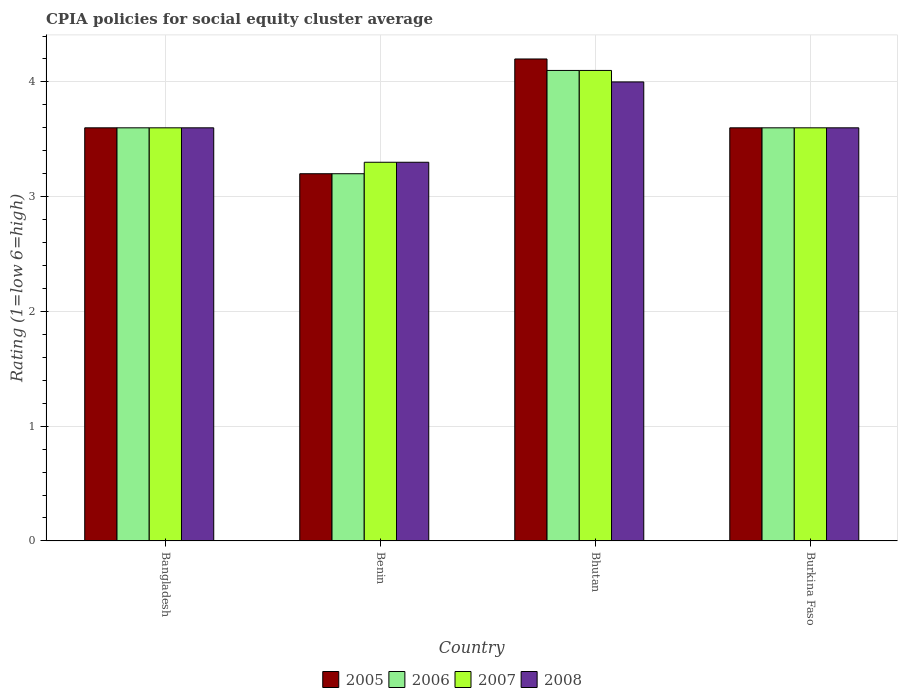How many groups of bars are there?
Provide a succinct answer. 4. How many bars are there on the 1st tick from the left?
Offer a terse response. 4. What is the label of the 2nd group of bars from the left?
Provide a succinct answer. Benin. Across all countries, what is the maximum CPIA rating in 2007?
Your answer should be very brief. 4.1. In which country was the CPIA rating in 2006 maximum?
Provide a succinct answer. Bhutan. In which country was the CPIA rating in 2007 minimum?
Provide a short and direct response. Benin. What is the total CPIA rating in 2008 in the graph?
Provide a succinct answer. 14.5. What is the difference between the CPIA rating in 2006 in Bangladesh and that in Burkina Faso?
Give a very brief answer. 0. What is the difference between the CPIA rating in 2007 in Benin and the CPIA rating in 2006 in Bangladesh?
Make the answer very short. -0.3. What is the average CPIA rating in 2007 per country?
Provide a short and direct response. 3.65. In how many countries, is the CPIA rating in 2007 greater than 2.2?
Your response must be concise. 4. What is the ratio of the CPIA rating in 2006 in Bangladesh to that in Burkina Faso?
Offer a terse response. 1. Is the CPIA rating in 2007 in Bhutan less than that in Burkina Faso?
Provide a succinct answer. No. Is the difference between the CPIA rating in 2008 in Bhutan and Burkina Faso greater than the difference between the CPIA rating in 2007 in Bhutan and Burkina Faso?
Provide a short and direct response. No. What is the difference between the highest and the second highest CPIA rating in 2007?
Provide a succinct answer. -0.5. Is the sum of the CPIA rating in 2008 in Benin and Burkina Faso greater than the maximum CPIA rating in 2006 across all countries?
Keep it short and to the point. Yes. Is it the case that in every country, the sum of the CPIA rating in 2008 and CPIA rating in 2007 is greater than the sum of CPIA rating in 2006 and CPIA rating in 2005?
Your response must be concise. No. What does the 1st bar from the right in Burkina Faso represents?
Make the answer very short. 2008. Are all the bars in the graph horizontal?
Ensure brevity in your answer.  No. Are the values on the major ticks of Y-axis written in scientific E-notation?
Your answer should be very brief. No. Does the graph contain any zero values?
Give a very brief answer. No. Does the graph contain grids?
Your response must be concise. Yes. How are the legend labels stacked?
Provide a short and direct response. Horizontal. What is the title of the graph?
Make the answer very short. CPIA policies for social equity cluster average. Does "1982" appear as one of the legend labels in the graph?
Your answer should be very brief. No. What is the label or title of the Y-axis?
Ensure brevity in your answer.  Rating (1=low 6=high). What is the Rating (1=low 6=high) of 2008 in Bangladesh?
Your response must be concise. 3.6. What is the Rating (1=low 6=high) of 2005 in Benin?
Ensure brevity in your answer.  3.2. What is the Rating (1=low 6=high) of 2008 in Benin?
Ensure brevity in your answer.  3.3. What is the Rating (1=low 6=high) in 2005 in Bhutan?
Provide a succinct answer. 4.2. What is the Rating (1=low 6=high) in 2008 in Bhutan?
Provide a short and direct response. 4. What is the Rating (1=low 6=high) of 2005 in Burkina Faso?
Provide a succinct answer. 3.6. What is the Rating (1=low 6=high) in 2008 in Burkina Faso?
Offer a terse response. 3.6. Across all countries, what is the maximum Rating (1=low 6=high) in 2005?
Make the answer very short. 4.2. Across all countries, what is the maximum Rating (1=low 6=high) of 2006?
Make the answer very short. 4.1. Across all countries, what is the maximum Rating (1=low 6=high) of 2007?
Offer a terse response. 4.1. Across all countries, what is the maximum Rating (1=low 6=high) in 2008?
Offer a very short reply. 4. Across all countries, what is the minimum Rating (1=low 6=high) of 2007?
Make the answer very short. 3.3. Across all countries, what is the minimum Rating (1=low 6=high) of 2008?
Your answer should be very brief. 3.3. What is the total Rating (1=low 6=high) of 2005 in the graph?
Your response must be concise. 14.6. What is the total Rating (1=low 6=high) in 2006 in the graph?
Your response must be concise. 14.5. What is the total Rating (1=low 6=high) of 2007 in the graph?
Your answer should be very brief. 14.6. What is the difference between the Rating (1=low 6=high) in 2005 in Bangladesh and that in Benin?
Keep it short and to the point. 0.4. What is the difference between the Rating (1=low 6=high) of 2006 in Bangladesh and that in Benin?
Offer a very short reply. 0.4. What is the difference between the Rating (1=low 6=high) of 2007 in Bangladesh and that in Benin?
Ensure brevity in your answer.  0.3. What is the difference between the Rating (1=low 6=high) in 2008 in Bangladesh and that in Benin?
Provide a succinct answer. 0.3. What is the difference between the Rating (1=low 6=high) of 2006 in Bangladesh and that in Bhutan?
Your answer should be very brief. -0.5. What is the difference between the Rating (1=low 6=high) in 2007 in Bangladesh and that in Bhutan?
Your response must be concise. -0.5. What is the difference between the Rating (1=low 6=high) of 2006 in Bangladesh and that in Burkina Faso?
Your answer should be compact. 0. What is the difference between the Rating (1=low 6=high) of 2008 in Bangladesh and that in Burkina Faso?
Give a very brief answer. 0. What is the difference between the Rating (1=low 6=high) of 2006 in Benin and that in Bhutan?
Give a very brief answer. -0.9. What is the difference between the Rating (1=low 6=high) of 2008 in Benin and that in Bhutan?
Provide a succinct answer. -0.7. What is the difference between the Rating (1=low 6=high) in 2005 in Benin and that in Burkina Faso?
Your answer should be very brief. -0.4. What is the difference between the Rating (1=low 6=high) of 2006 in Benin and that in Burkina Faso?
Your answer should be compact. -0.4. What is the difference between the Rating (1=low 6=high) in 2007 in Benin and that in Burkina Faso?
Your answer should be compact. -0.3. What is the difference between the Rating (1=low 6=high) of 2008 in Benin and that in Burkina Faso?
Offer a very short reply. -0.3. What is the difference between the Rating (1=low 6=high) of 2005 in Bangladesh and the Rating (1=low 6=high) of 2007 in Benin?
Your answer should be compact. 0.3. What is the difference between the Rating (1=low 6=high) in 2005 in Bangladesh and the Rating (1=low 6=high) in 2008 in Benin?
Ensure brevity in your answer.  0.3. What is the difference between the Rating (1=low 6=high) of 2006 in Bangladesh and the Rating (1=low 6=high) of 2007 in Benin?
Make the answer very short. 0.3. What is the difference between the Rating (1=low 6=high) in 2007 in Bangladesh and the Rating (1=low 6=high) in 2008 in Benin?
Ensure brevity in your answer.  0.3. What is the difference between the Rating (1=low 6=high) in 2005 in Bangladesh and the Rating (1=low 6=high) in 2007 in Bhutan?
Offer a very short reply. -0.5. What is the difference between the Rating (1=low 6=high) of 2006 in Bangladesh and the Rating (1=low 6=high) of 2008 in Bhutan?
Your answer should be very brief. -0.4. What is the difference between the Rating (1=low 6=high) in 2005 in Bangladesh and the Rating (1=low 6=high) in 2007 in Burkina Faso?
Your response must be concise. 0. What is the difference between the Rating (1=low 6=high) of 2006 in Bangladesh and the Rating (1=low 6=high) of 2007 in Burkina Faso?
Give a very brief answer. 0. What is the difference between the Rating (1=low 6=high) in 2006 in Bangladesh and the Rating (1=low 6=high) in 2008 in Burkina Faso?
Your answer should be compact. 0. What is the difference between the Rating (1=low 6=high) of 2007 in Bangladesh and the Rating (1=low 6=high) of 2008 in Burkina Faso?
Offer a terse response. 0. What is the difference between the Rating (1=low 6=high) of 2005 in Benin and the Rating (1=low 6=high) of 2008 in Bhutan?
Offer a terse response. -0.8. What is the difference between the Rating (1=low 6=high) in 2006 in Benin and the Rating (1=low 6=high) in 2007 in Bhutan?
Provide a short and direct response. -0.9. What is the difference between the Rating (1=low 6=high) in 2005 in Benin and the Rating (1=low 6=high) in 2006 in Burkina Faso?
Offer a terse response. -0.4. What is the difference between the Rating (1=low 6=high) of 2005 in Benin and the Rating (1=low 6=high) of 2007 in Burkina Faso?
Provide a succinct answer. -0.4. What is the difference between the Rating (1=low 6=high) of 2005 in Benin and the Rating (1=low 6=high) of 2008 in Burkina Faso?
Offer a terse response. -0.4. What is the difference between the Rating (1=low 6=high) in 2006 in Benin and the Rating (1=low 6=high) in 2007 in Burkina Faso?
Offer a terse response. -0.4. What is the difference between the Rating (1=low 6=high) of 2006 in Benin and the Rating (1=low 6=high) of 2008 in Burkina Faso?
Give a very brief answer. -0.4. What is the difference between the Rating (1=low 6=high) of 2005 in Bhutan and the Rating (1=low 6=high) of 2006 in Burkina Faso?
Your answer should be very brief. 0.6. What is the difference between the Rating (1=low 6=high) in 2005 in Bhutan and the Rating (1=low 6=high) in 2007 in Burkina Faso?
Your answer should be very brief. 0.6. What is the difference between the Rating (1=low 6=high) of 2005 in Bhutan and the Rating (1=low 6=high) of 2008 in Burkina Faso?
Offer a terse response. 0.6. What is the difference between the Rating (1=low 6=high) in 2006 in Bhutan and the Rating (1=low 6=high) in 2007 in Burkina Faso?
Keep it short and to the point. 0.5. What is the difference between the Rating (1=low 6=high) of 2006 in Bhutan and the Rating (1=low 6=high) of 2008 in Burkina Faso?
Your answer should be compact. 0.5. What is the average Rating (1=low 6=high) in 2005 per country?
Keep it short and to the point. 3.65. What is the average Rating (1=low 6=high) of 2006 per country?
Keep it short and to the point. 3.62. What is the average Rating (1=low 6=high) in 2007 per country?
Ensure brevity in your answer.  3.65. What is the average Rating (1=low 6=high) in 2008 per country?
Make the answer very short. 3.62. What is the difference between the Rating (1=low 6=high) in 2005 and Rating (1=low 6=high) in 2007 in Bangladesh?
Provide a succinct answer. 0. What is the difference between the Rating (1=low 6=high) in 2005 and Rating (1=low 6=high) in 2008 in Bangladesh?
Your answer should be compact. 0. What is the difference between the Rating (1=low 6=high) of 2006 and Rating (1=low 6=high) of 2007 in Bangladesh?
Your answer should be very brief. 0. What is the difference between the Rating (1=low 6=high) of 2007 and Rating (1=low 6=high) of 2008 in Bangladesh?
Keep it short and to the point. 0. What is the difference between the Rating (1=low 6=high) in 2005 and Rating (1=low 6=high) in 2007 in Benin?
Keep it short and to the point. -0.1. What is the difference between the Rating (1=low 6=high) of 2006 and Rating (1=low 6=high) of 2008 in Benin?
Your response must be concise. -0.1. What is the difference between the Rating (1=low 6=high) of 2005 and Rating (1=low 6=high) of 2006 in Bhutan?
Offer a very short reply. 0.1. What is the difference between the Rating (1=low 6=high) of 2006 and Rating (1=low 6=high) of 2007 in Bhutan?
Give a very brief answer. 0. What is the difference between the Rating (1=low 6=high) of 2006 and Rating (1=low 6=high) of 2008 in Bhutan?
Provide a succinct answer. 0.1. What is the difference between the Rating (1=low 6=high) of 2005 and Rating (1=low 6=high) of 2006 in Burkina Faso?
Your response must be concise. 0. What is the difference between the Rating (1=low 6=high) of 2006 and Rating (1=low 6=high) of 2007 in Burkina Faso?
Provide a short and direct response. 0. What is the difference between the Rating (1=low 6=high) of 2006 and Rating (1=low 6=high) of 2008 in Burkina Faso?
Give a very brief answer. 0. What is the ratio of the Rating (1=low 6=high) of 2006 in Bangladesh to that in Benin?
Make the answer very short. 1.12. What is the ratio of the Rating (1=low 6=high) in 2007 in Bangladesh to that in Benin?
Ensure brevity in your answer.  1.09. What is the ratio of the Rating (1=low 6=high) of 2006 in Bangladesh to that in Bhutan?
Provide a succinct answer. 0.88. What is the ratio of the Rating (1=low 6=high) of 2007 in Bangladesh to that in Bhutan?
Provide a short and direct response. 0.88. What is the ratio of the Rating (1=low 6=high) in 2008 in Bangladesh to that in Burkina Faso?
Provide a short and direct response. 1. What is the ratio of the Rating (1=low 6=high) in 2005 in Benin to that in Bhutan?
Give a very brief answer. 0.76. What is the ratio of the Rating (1=low 6=high) of 2006 in Benin to that in Bhutan?
Offer a very short reply. 0.78. What is the ratio of the Rating (1=low 6=high) in 2007 in Benin to that in Bhutan?
Provide a succinct answer. 0.8. What is the ratio of the Rating (1=low 6=high) in 2008 in Benin to that in Bhutan?
Make the answer very short. 0.82. What is the ratio of the Rating (1=low 6=high) in 2006 in Benin to that in Burkina Faso?
Your answer should be compact. 0.89. What is the ratio of the Rating (1=low 6=high) in 2007 in Benin to that in Burkina Faso?
Offer a terse response. 0.92. What is the ratio of the Rating (1=low 6=high) of 2008 in Benin to that in Burkina Faso?
Offer a terse response. 0.92. What is the ratio of the Rating (1=low 6=high) of 2006 in Bhutan to that in Burkina Faso?
Your answer should be very brief. 1.14. What is the ratio of the Rating (1=low 6=high) of 2007 in Bhutan to that in Burkina Faso?
Keep it short and to the point. 1.14. What is the difference between the highest and the second highest Rating (1=low 6=high) in 2007?
Provide a short and direct response. 0.5. What is the difference between the highest and the second highest Rating (1=low 6=high) of 2008?
Offer a terse response. 0.4. What is the difference between the highest and the lowest Rating (1=low 6=high) of 2006?
Provide a short and direct response. 0.9. What is the difference between the highest and the lowest Rating (1=low 6=high) in 2007?
Provide a short and direct response. 0.8. 